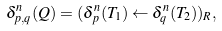<formula> <loc_0><loc_0><loc_500><loc_500>\delta ^ { n } _ { p , q } ( Q ) = ( \delta ^ { n } _ { p } ( T _ { 1 } ) \leftarrow \delta ^ { n } _ { q } ( T _ { 2 } ) ) _ { R } ,</formula> 